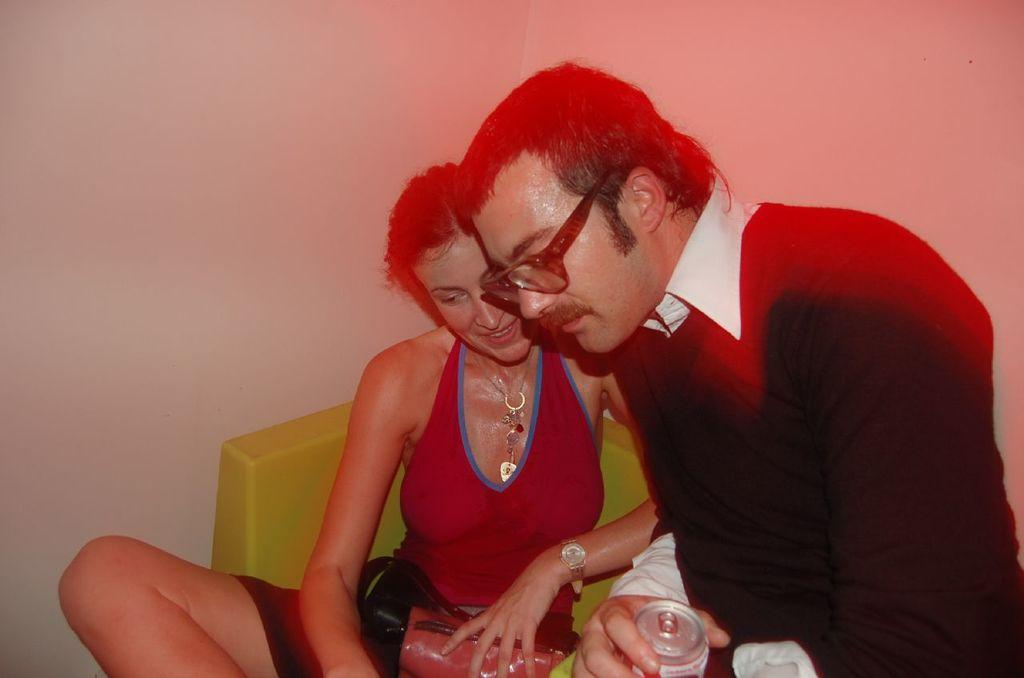What is the woman doing in the image? The woman is sitting on a chair in the image. What is the man holding in the image? The man is holding a tin in the image. What can be seen behind the two persons in the image? There is a wall visible behind the two persons in the image. How many cars can be seen parked in front of the wall in the image? There are no cars visible in the image; only a woman sitting on a chair, a man holding a tin, and a wall are present. 